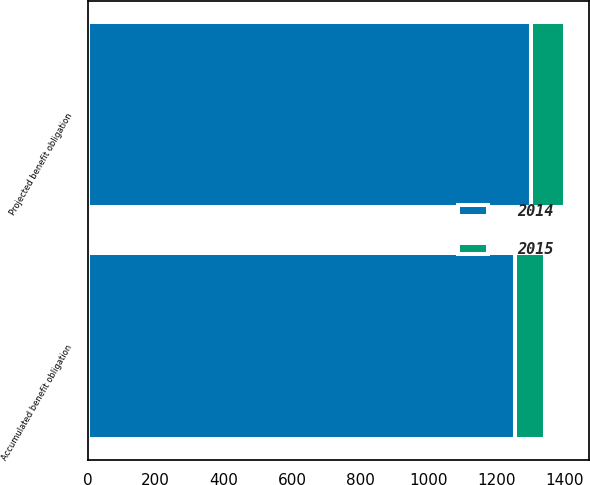Convert chart. <chart><loc_0><loc_0><loc_500><loc_500><stacked_bar_chart><ecel><fcel>Projected benefit obligation<fcel>Accumulated benefit obligation<nl><fcel>2015<fcel>101<fcel>88<nl><fcel>2014<fcel>1301<fcel>1254<nl></chart> 